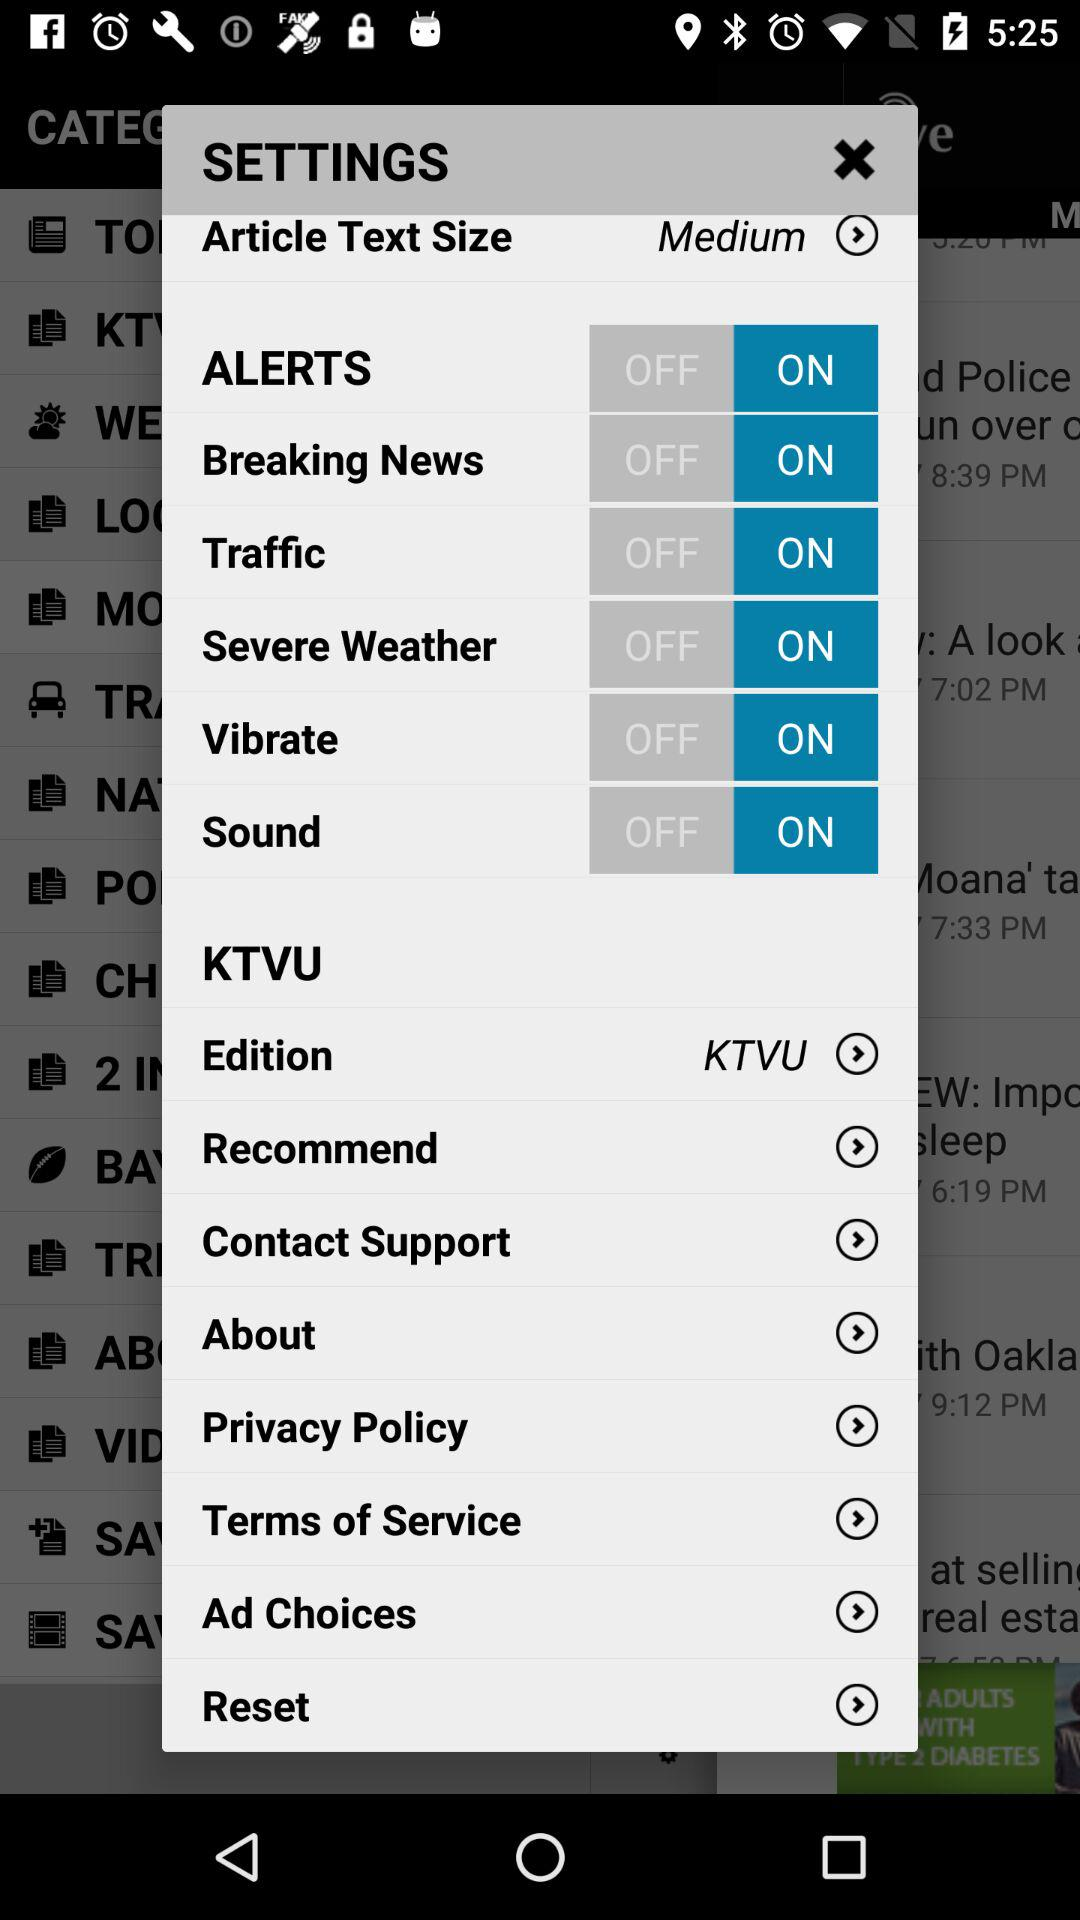What is the current status of the "Breaking News"? The current status is "on". 